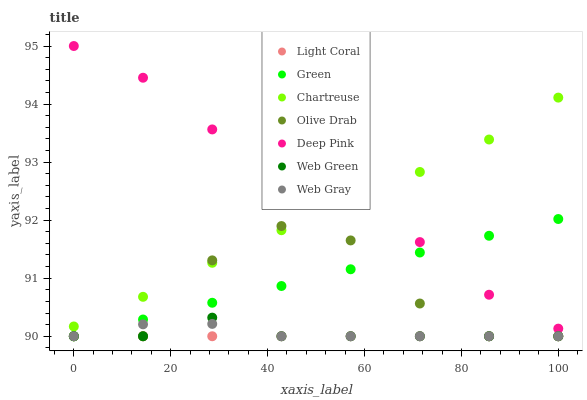Does Light Coral have the minimum area under the curve?
Answer yes or no. Yes. Does Deep Pink have the maximum area under the curve?
Answer yes or no. Yes. Does Web Green have the minimum area under the curve?
Answer yes or no. No. Does Web Green have the maximum area under the curve?
Answer yes or no. No. Is Light Coral the smoothest?
Answer yes or no. Yes. Is Olive Drab the roughest?
Answer yes or no. Yes. Is Web Green the smoothest?
Answer yes or no. No. Is Web Green the roughest?
Answer yes or no. No. Does Web Green have the lowest value?
Answer yes or no. Yes. Does Chartreuse have the lowest value?
Answer yes or no. No. Does Deep Pink have the highest value?
Answer yes or no. Yes. Does Web Green have the highest value?
Answer yes or no. No. Is Web Gray less than Chartreuse?
Answer yes or no. Yes. Is Chartreuse greater than Web Green?
Answer yes or no. Yes. Does Web Green intersect Olive Drab?
Answer yes or no. Yes. Is Web Green less than Olive Drab?
Answer yes or no. No. Is Web Green greater than Olive Drab?
Answer yes or no. No. Does Web Gray intersect Chartreuse?
Answer yes or no. No. 